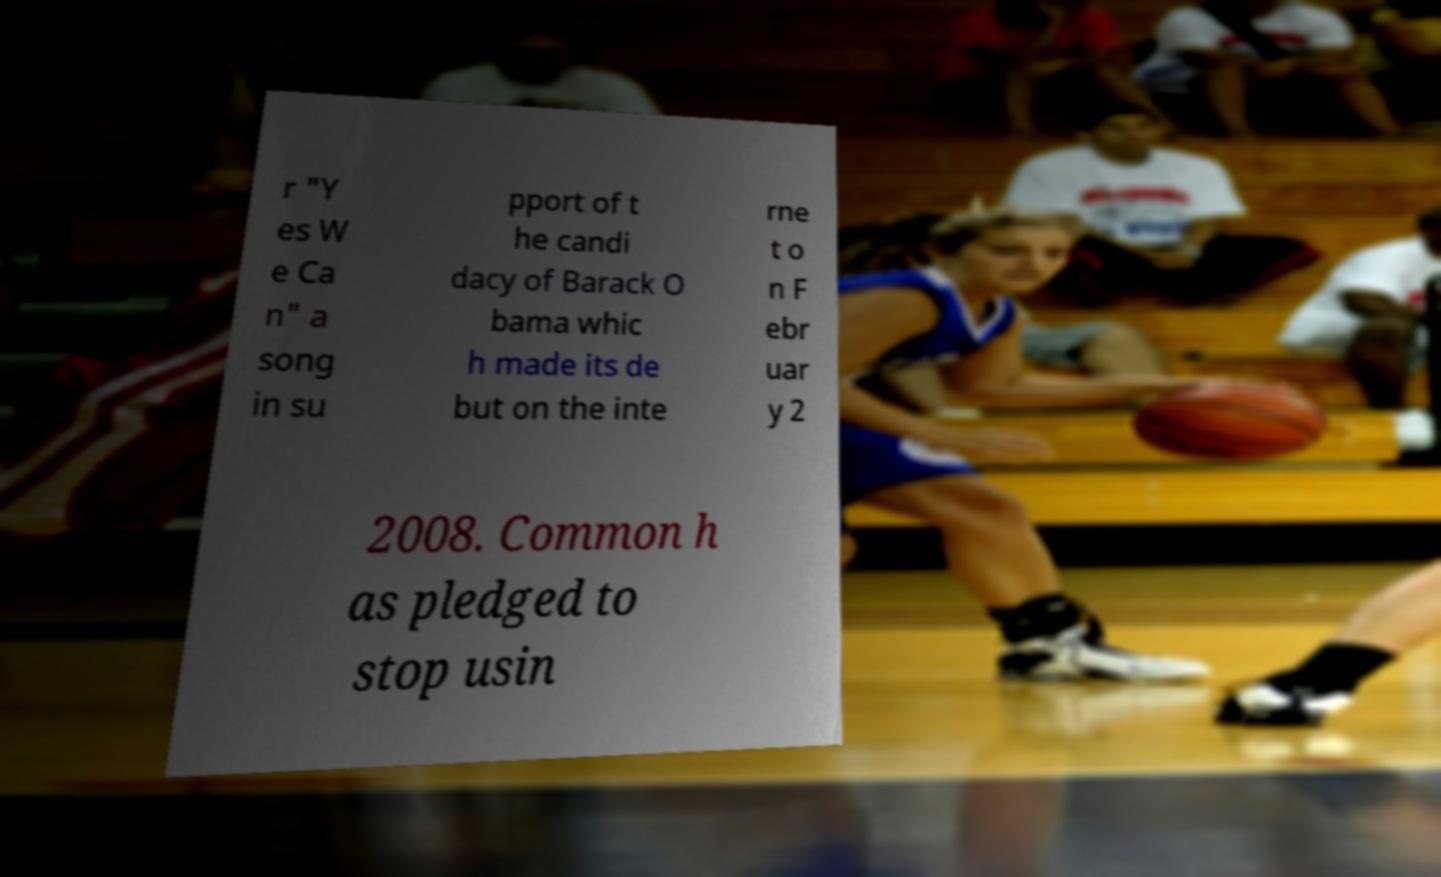What messages or text are displayed in this image? I need them in a readable, typed format. r "Y es W e Ca n" a song in su pport of t he candi dacy of Barack O bama whic h made its de but on the inte rne t o n F ebr uar y 2 2008. Common h as pledged to stop usin 